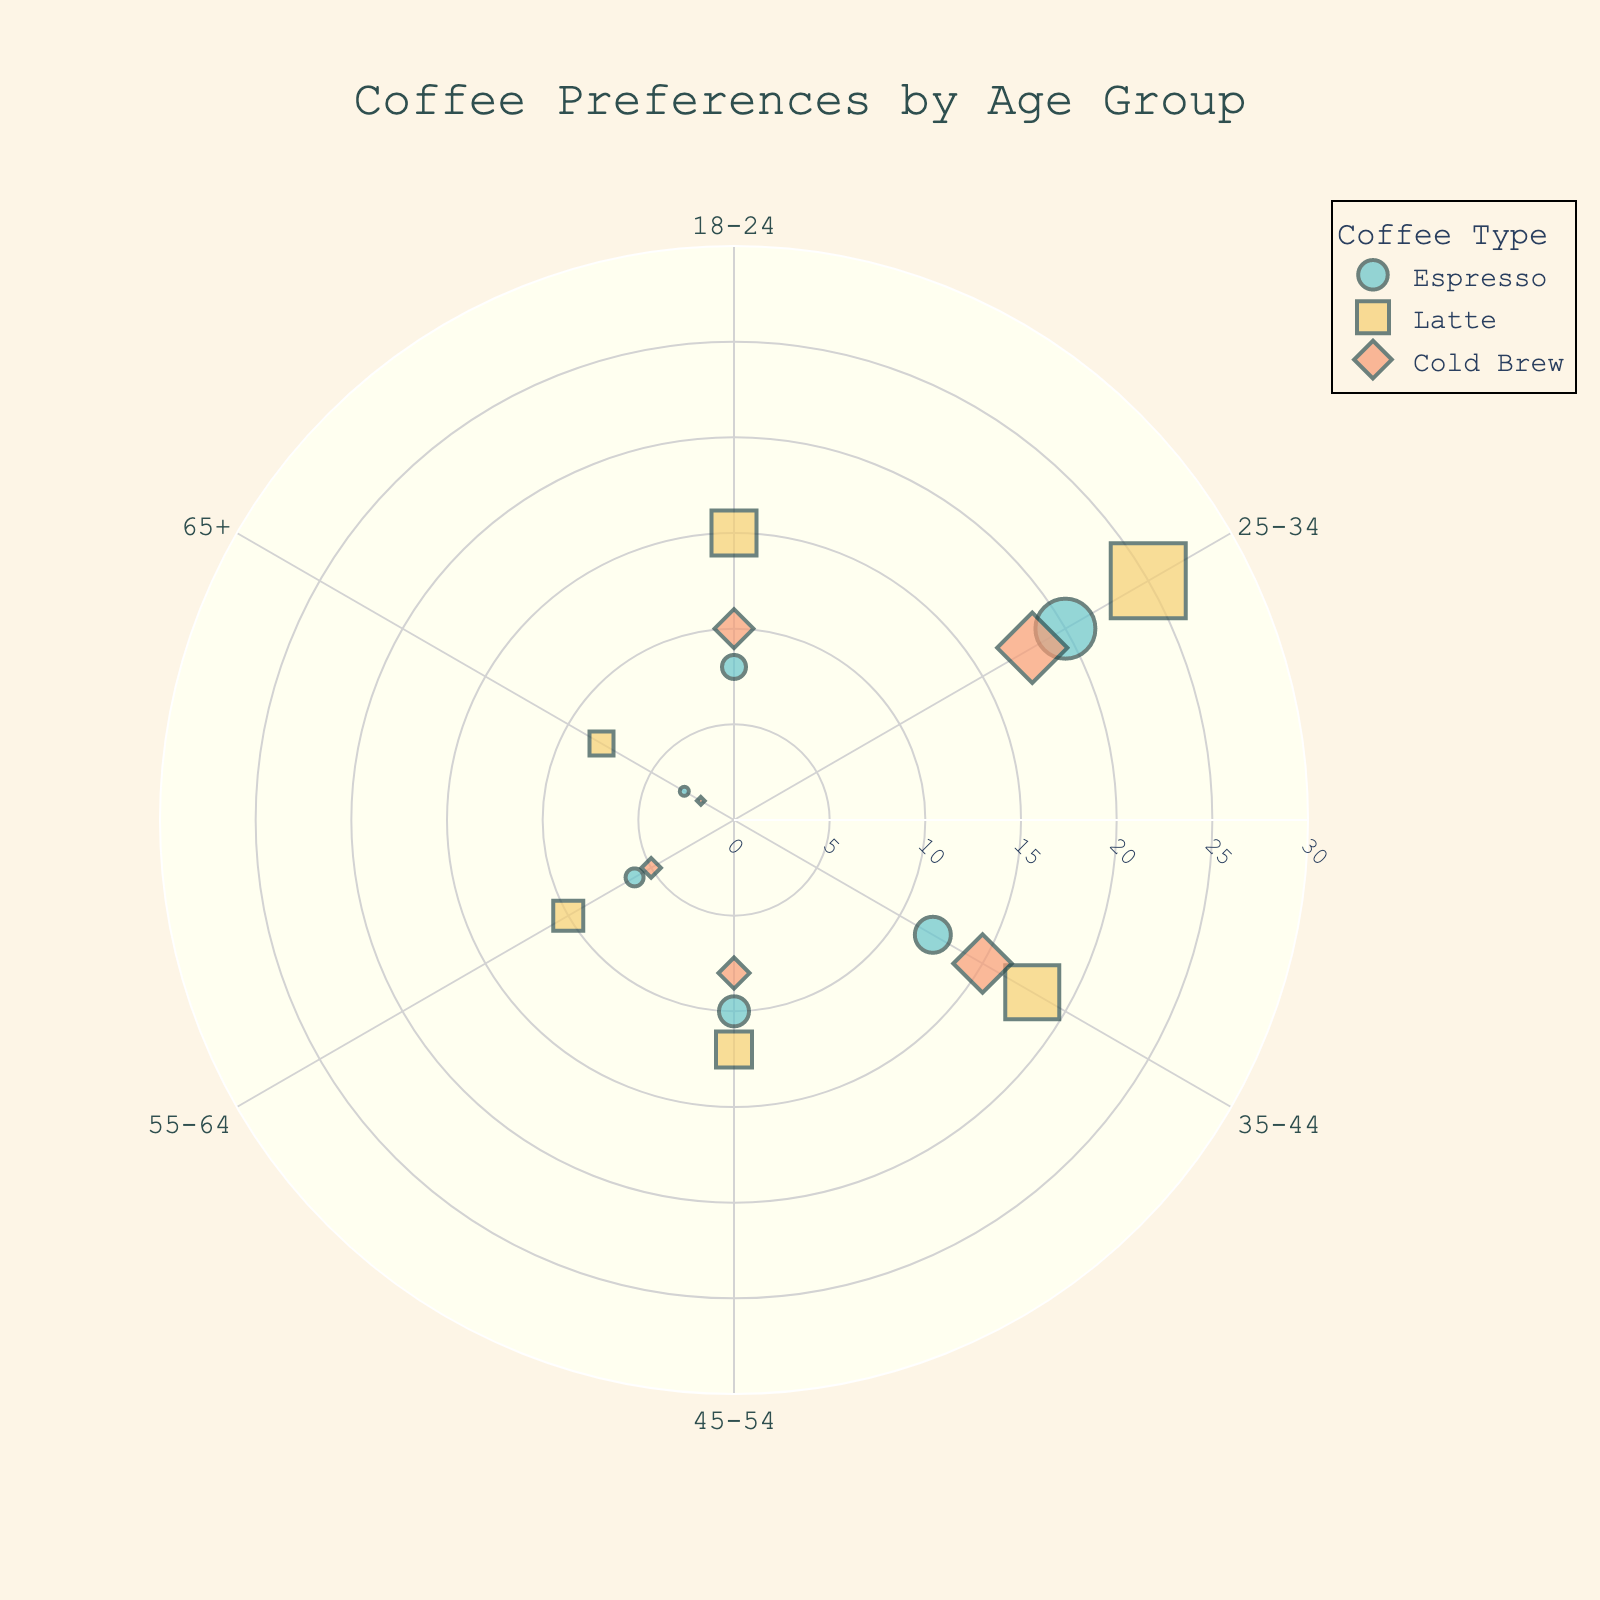What are the age groups listed in the chart? The chart categorizes customers into several age groups. These groups are visible as the angular axis labels around the polar chart. They are in order: 18-24, 25-34, 35-44, 45-54, 55-64, and 65+.
Answer: 18-24, 25-34, 35-44, 45-54, 55-64, 65+ Which coffee type has the highest preference level among 25-34 age group? Looking at the polar scatter plot for the 25-34 age group, identify which coffee type has the marker furthest from the center (indicating the highest preference level). The chart shows that the Latte has the highest preference level in this age group.
Answer: Latte What's the average preference level for Espresso across all age groups? Sum the preference levels for Espresso for all age groups: 8 (18-24) + 20 (25-34) + 12 (35-44) + 10 (45-54) + 6 (55-64) + 3 (65+). The sum is 59. Divide this by the number of age groups, which is 6. 59/6 equals approximately 9.83.
Answer: ~9.83 Which age group shows the least preference for Cold Brew? The least preferred level for Cold Brew is observed by finding the smallest marker on the chart for Cold Brew. The 65+ age group has the smallest preference level marker, which is located closest to the center.
Answer: 65+ Is the preference level for Latte greater among 18-24 or 35-44 age group? Compare the position of the Latte markers for the 18-24 and 35-44 age groups. The marker for 18-24 is further from the center at level 15, while the marker for 35-44 is at level 18. Therefore, the preference level for Latte is greater among 35-44.
Answer: 35-44 Determine the range of preference levels for Cold Brew among all age groups. Identify the highest and lowest preference levels for Cold Brew. The highest is 18 (25-34) and the lowest is 2 (65+). The range is calculated as the difference between the highest and lowest values, 18 - 2 = 16.
Answer: 16 How many coffee types have a preference level greater than 10 in 45-54 age group? Look at the 45-54 markers. Each coffee type marker's distance from the center shows the preference level. Espresso (10), Latte (12), and Cold Brew (8) are observed. Only Latte has a preference level greater than 10.
Answer: 1 Which age group has the most diverse coffee preferences in terms of the spread of preference levels? Look at the spread (range) of preference levels for each age group. Calculate the range by subtracting the smallest preference level from the largest for each age group. The 25-34 age group has the widest spread, with Espresso at 20, Latte at 25, and Cold Brew at 18, totalling a range of 25 - 18 = 7.
Answer: 25-34 Between 18-24 and 55-64 age groups, which has a higher maximum preference level and for which coffee type? For 18-24, the highest preference level is Latte at 15. For 55-64, the highest is Latte at 10. Therefore, 18-24 age group has the higher maximum preference level for Latte.
Answer: 18-24, Latte 